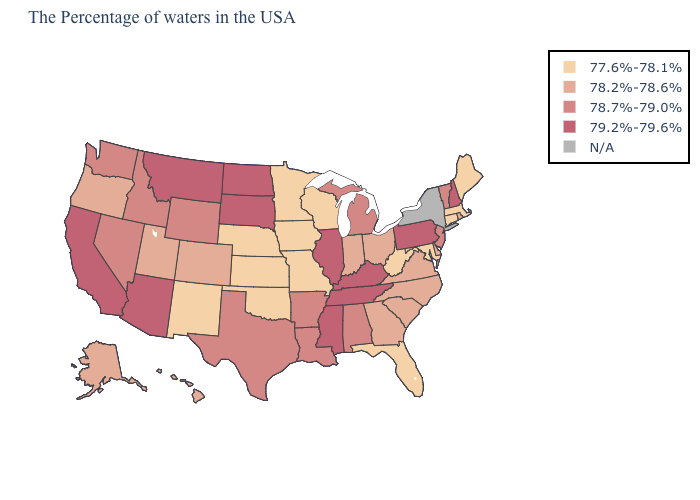Does Pennsylvania have the highest value in the USA?
Give a very brief answer. Yes. What is the lowest value in the USA?
Answer briefly. 77.6%-78.1%. What is the value of Florida?
Answer briefly. 77.6%-78.1%. Name the states that have a value in the range 77.6%-78.1%?
Give a very brief answer. Maine, Massachusetts, Connecticut, Maryland, West Virginia, Florida, Wisconsin, Missouri, Minnesota, Iowa, Kansas, Nebraska, Oklahoma, New Mexico. Which states have the lowest value in the South?
Write a very short answer. Maryland, West Virginia, Florida, Oklahoma. What is the highest value in the USA?
Give a very brief answer. 79.2%-79.6%. Does the first symbol in the legend represent the smallest category?
Short answer required. Yes. What is the value of Wisconsin?
Keep it brief. 77.6%-78.1%. Is the legend a continuous bar?
Quick response, please. No. Name the states that have a value in the range 77.6%-78.1%?
Short answer required. Maine, Massachusetts, Connecticut, Maryland, West Virginia, Florida, Wisconsin, Missouri, Minnesota, Iowa, Kansas, Nebraska, Oklahoma, New Mexico. Which states have the lowest value in the USA?
Be succinct. Maine, Massachusetts, Connecticut, Maryland, West Virginia, Florida, Wisconsin, Missouri, Minnesota, Iowa, Kansas, Nebraska, Oklahoma, New Mexico. What is the value of Rhode Island?
Short answer required. 78.2%-78.6%. Name the states that have a value in the range 77.6%-78.1%?
Give a very brief answer. Maine, Massachusetts, Connecticut, Maryland, West Virginia, Florida, Wisconsin, Missouri, Minnesota, Iowa, Kansas, Nebraska, Oklahoma, New Mexico. 